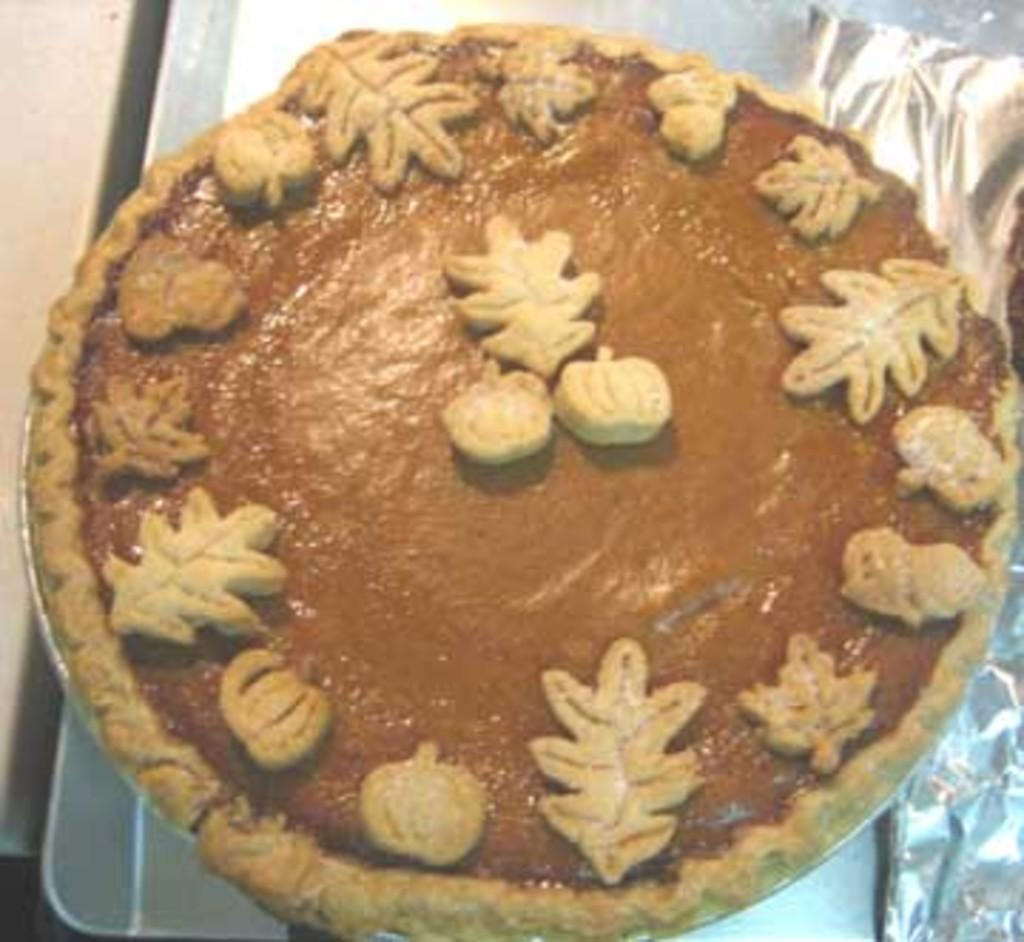What can be seen in the image related to food? There is food in the image. Can you describe any specific item related to food preparation or serving? There is an aluminium foil on the right side of the image. What type of flower can be seen growing in the image? There is no flower present in the image. Can you tell me the credit score of the person in the image? There is no person present in the image, and therefore no credit score can be determined. 